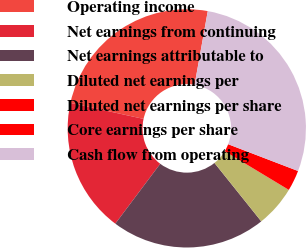<chart> <loc_0><loc_0><loc_500><loc_500><pie_chart><fcel>Operating income<fcel>Net earnings from continuing<fcel>Net earnings attributable to<fcel>Diluted net earnings per<fcel>Diluted net earnings per share<fcel>Core earnings per share<fcel>Cash flow from operating<nl><fcel>24.39%<fcel>18.19%<fcel>20.99%<fcel>5.61%<fcel>0.01%<fcel>2.81%<fcel>28.01%<nl></chart> 